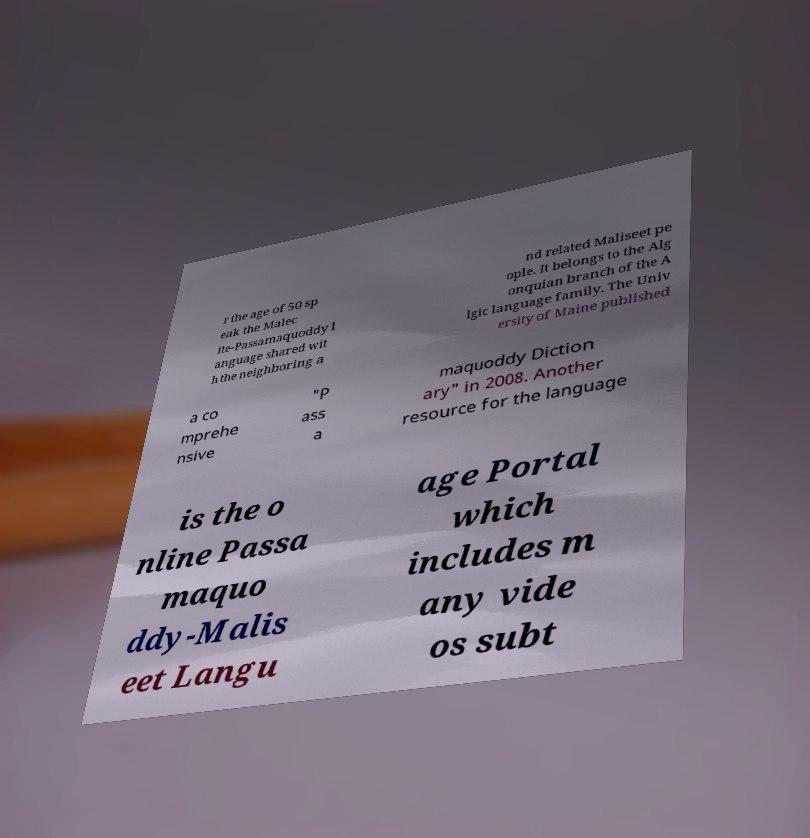I need the written content from this picture converted into text. Can you do that? r the age of 50 sp eak the Malec ite-Passamaquoddy l anguage shared wit h the neighboring a nd related Maliseet pe ople. It belongs to the Alg onquian branch of the A lgic language family. The Univ ersity of Maine published a co mprehe nsive "P ass a maquoddy Diction ary" in 2008. Another resource for the language is the o nline Passa maquo ddy-Malis eet Langu age Portal which includes m any vide os subt 